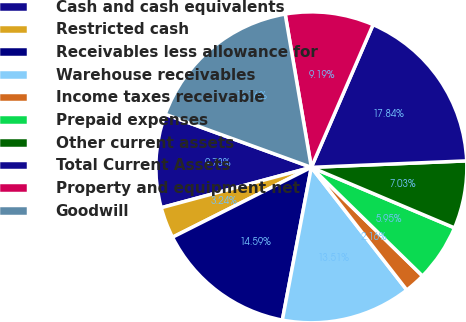Convert chart. <chart><loc_0><loc_0><loc_500><loc_500><pie_chart><fcel>Cash and cash equivalents<fcel>Restricted cash<fcel>Receivables less allowance for<fcel>Warehouse receivables<fcel>Income taxes receivable<fcel>Prepaid expenses<fcel>Other current assets<fcel>Total Current Assets<fcel>Property and equipment net<fcel>Goodwill<nl><fcel>9.73%<fcel>3.24%<fcel>14.59%<fcel>13.51%<fcel>2.16%<fcel>5.95%<fcel>7.03%<fcel>17.84%<fcel>9.19%<fcel>16.76%<nl></chart> 